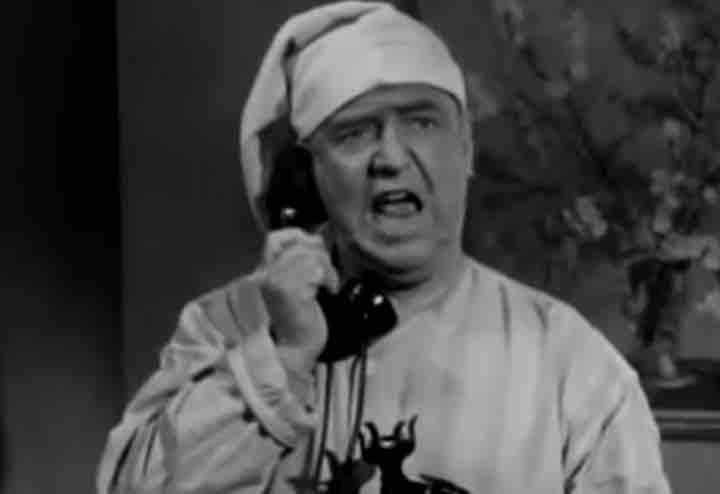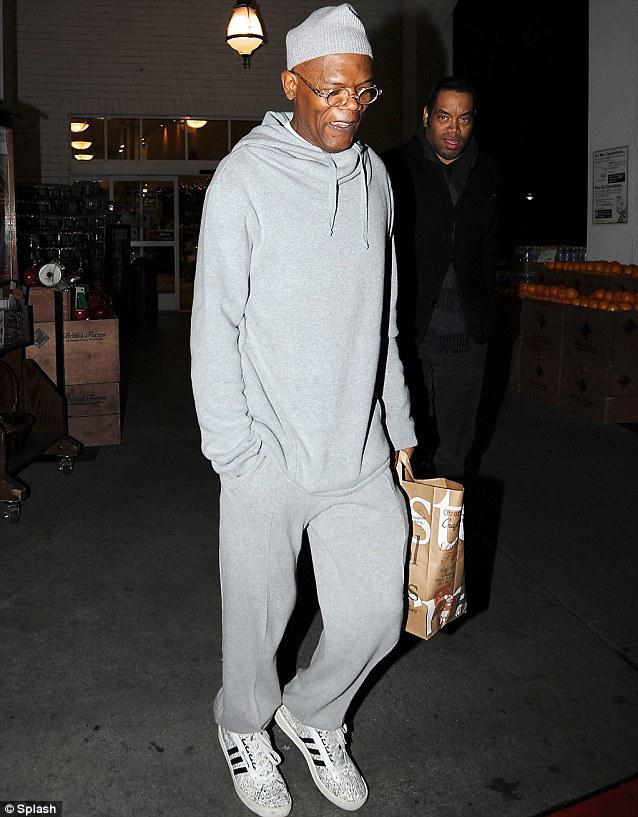The first image is the image on the left, the second image is the image on the right. Assess this claim about the two images: "the right image shows a man in a seated position wearing blue, long sleeved pajamas". Correct or not? Answer yes or no. No. The first image is the image on the left, the second image is the image on the right. Considering the images on both sides, is "An image includes one forward-facing man in sleepwear who is lifting a corded black telephone to his ear, and the other image shows a man standing wearing grey sweatpants." valid? Answer yes or no. Yes. 